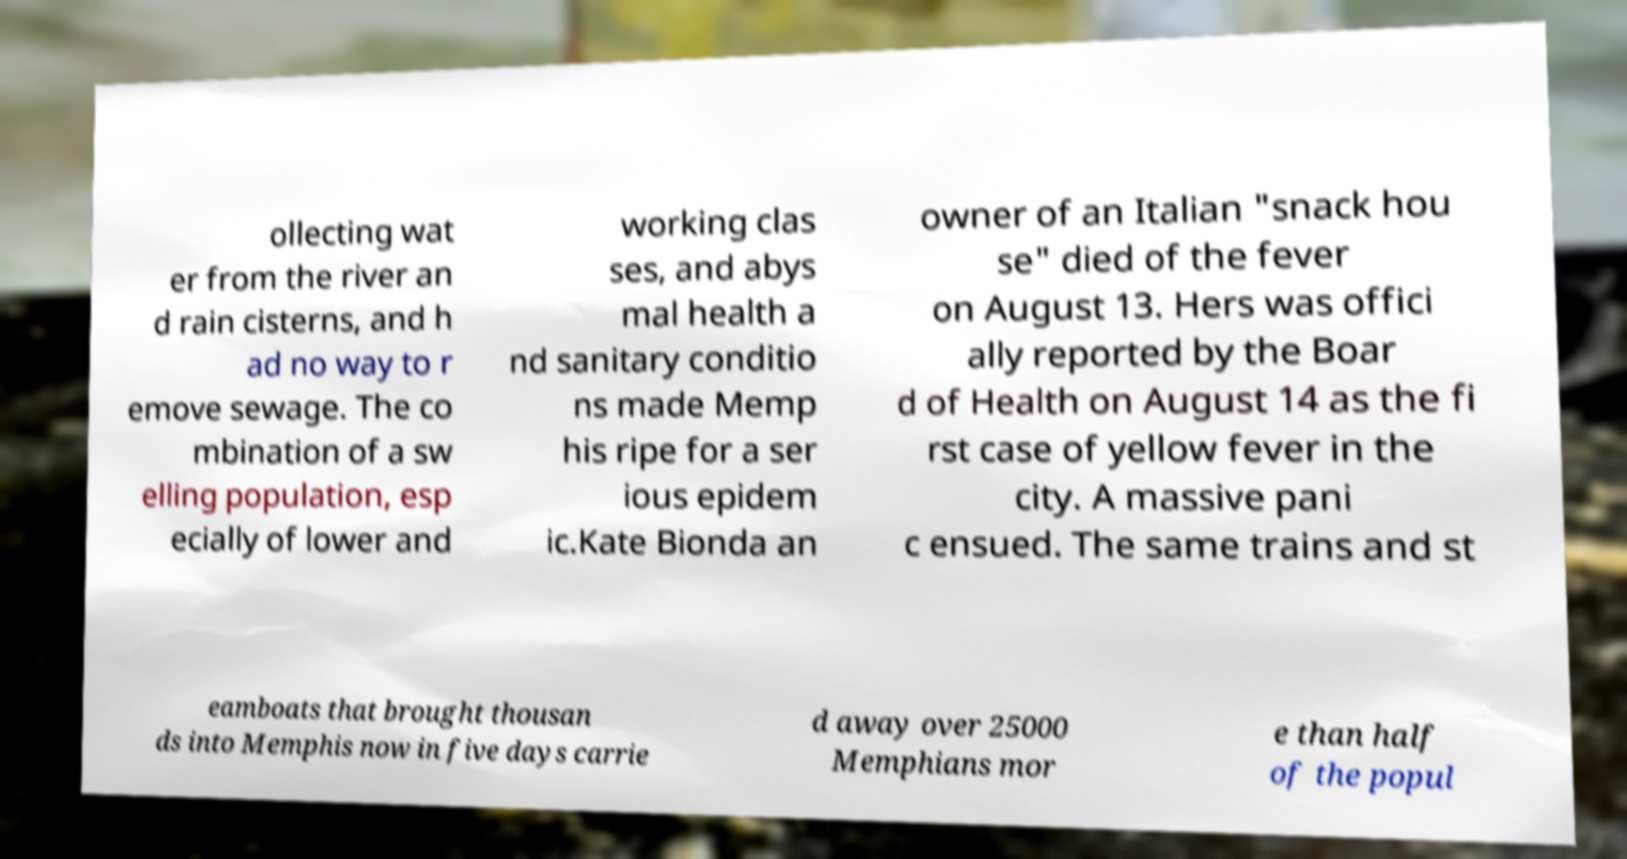Please identify and transcribe the text found in this image. ollecting wat er from the river an d rain cisterns, and h ad no way to r emove sewage. The co mbination of a sw elling population, esp ecially of lower and working clas ses, and abys mal health a nd sanitary conditio ns made Memp his ripe for a ser ious epidem ic.Kate Bionda an owner of an Italian "snack hou se" died of the fever on August 13. Hers was offici ally reported by the Boar d of Health on August 14 as the fi rst case of yellow fever in the city. A massive pani c ensued. The same trains and st eamboats that brought thousan ds into Memphis now in five days carrie d away over 25000 Memphians mor e than half of the popul 